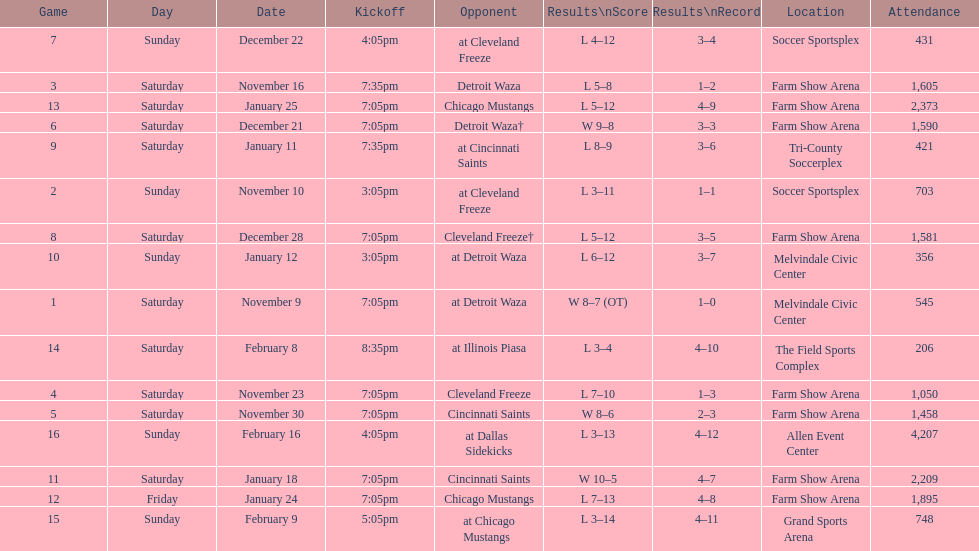How many games did the harrisburg heat lose to the cleveland freeze in total. 4. 